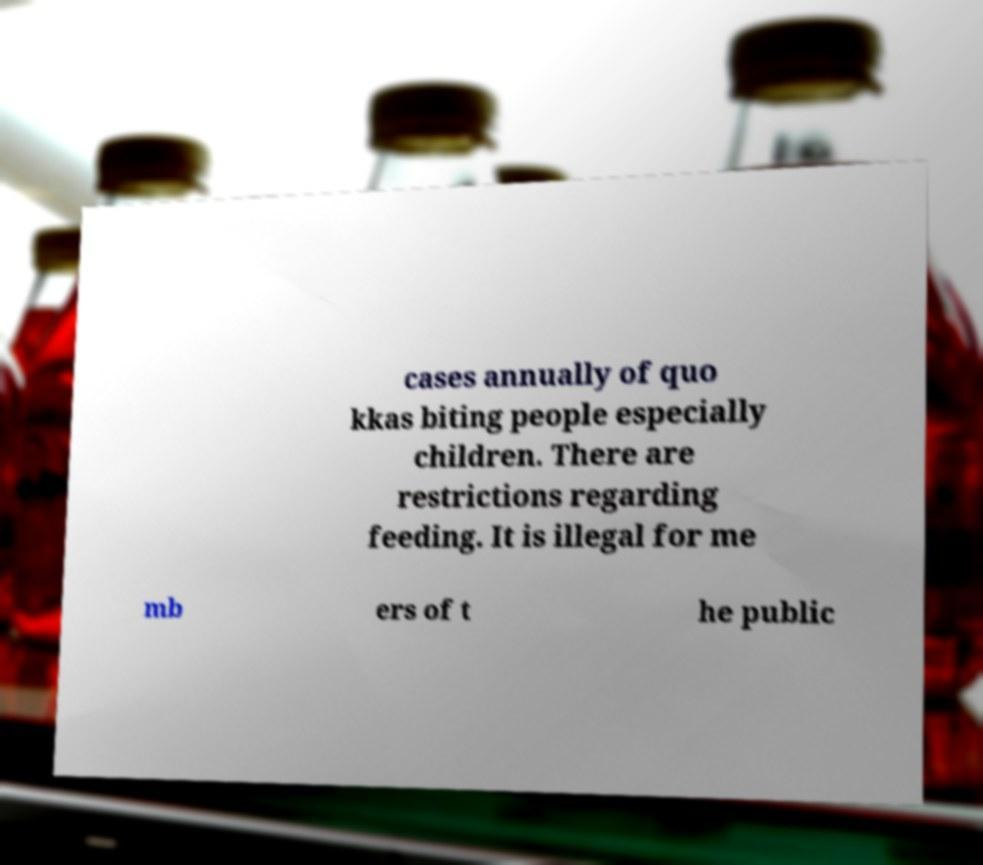I need the written content from this picture converted into text. Can you do that? cases annually of quo kkas biting people especially children. There are restrictions regarding feeding. It is illegal for me mb ers of t he public 